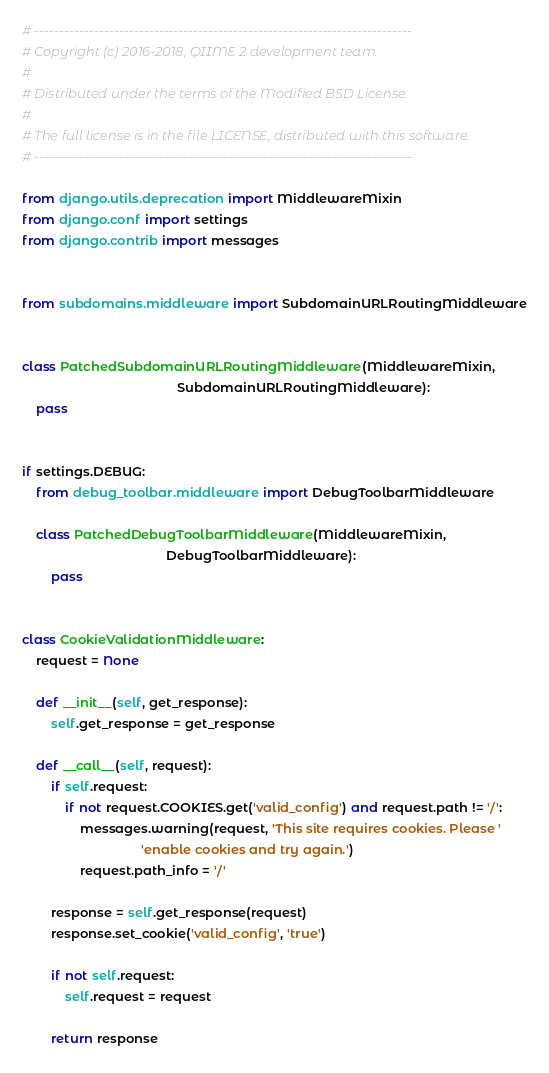Convert code to text. <code><loc_0><loc_0><loc_500><loc_500><_Python_># ----------------------------------------------------------------------------
# Copyright (c) 2016-2018, QIIME 2 development team.
#
# Distributed under the terms of the Modified BSD License.
#
# The full license is in the file LICENSE, distributed with this software.
# ----------------------------------------------------------------------------

from django.utils.deprecation import MiddlewareMixin
from django.conf import settings
from django.contrib import messages


from subdomains.middleware import SubdomainURLRoutingMiddleware


class PatchedSubdomainURLRoutingMiddleware(MiddlewareMixin,
                                           SubdomainURLRoutingMiddleware):
    pass


if settings.DEBUG:
    from debug_toolbar.middleware import DebugToolbarMiddleware

    class PatchedDebugToolbarMiddleware(MiddlewareMixin,
                                        DebugToolbarMiddleware):
        pass


class CookieValidationMiddleware:
    request = None

    def __init__(self, get_response):
        self.get_response = get_response

    def __call__(self, request):
        if self.request:
            if not request.COOKIES.get('valid_config') and request.path != '/':
                messages.warning(request, 'This site requires cookies. Please '
                                 'enable cookies and try again.')
                request.path_info = '/'

        response = self.get_response(request)
        response.set_cookie('valid_config', 'true')

        if not self.request:
            self.request = request

        return response
</code> 